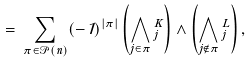<formula> <loc_0><loc_0><loc_500><loc_500>\Psi \, = \, \sum _ { \pi \in { \mathcal { P } } ( n ) } ( - 1 ) ^ { | \pi | } \left ( \bigwedge _ { j \in \pi } \Psi _ { j } ^ { K } \right ) \land \left ( \bigwedge _ { j \not \in \pi } \Psi _ { j } ^ { L } \right ) ,</formula> 